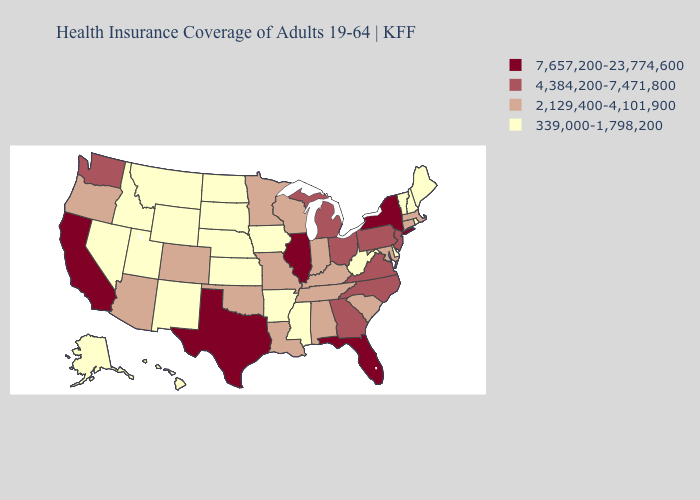Does Alabama have the same value as New Hampshire?
Write a very short answer. No. Name the states that have a value in the range 7,657,200-23,774,600?
Concise answer only. California, Florida, Illinois, New York, Texas. Name the states that have a value in the range 2,129,400-4,101,900?
Short answer required. Alabama, Arizona, Colorado, Connecticut, Indiana, Kentucky, Louisiana, Maryland, Massachusetts, Minnesota, Missouri, Oklahoma, Oregon, South Carolina, Tennessee, Wisconsin. What is the value of Illinois?
Short answer required. 7,657,200-23,774,600. Does California have the same value as Texas?
Short answer required. Yes. Which states have the highest value in the USA?
Quick response, please. California, Florida, Illinois, New York, Texas. What is the value of Virginia?
Keep it brief. 4,384,200-7,471,800. Does the first symbol in the legend represent the smallest category?
Short answer required. No. What is the value of Maryland?
Quick response, please. 2,129,400-4,101,900. Which states have the lowest value in the USA?
Short answer required. Alaska, Arkansas, Delaware, Hawaii, Idaho, Iowa, Kansas, Maine, Mississippi, Montana, Nebraska, Nevada, New Hampshire, New Mexico, North Dakota, Rhode Island, South Dakota, Utah, Vermont, West Virginia, Wyoming. Does the map have missing data?
Quick response, please. No. Name the states that have a value in the range 2,129,400-4,101,900?
Keep it brief. Alabama, Arizona, Colorado, Connecticut, Indiana, Kentucky, Louisiana, Maryland, Massachusetts, Minnesota, Missouri, Oklahoma, Oregon, South Carolina, Tennessee, Wisconsin. What is the value of New Hampshire?
Short answer required. 339,000-1,798,200. What is the value of New Jersey?
Be succinct. 4,384,200-7,471,800. Is the legend a continuous bar?
Answer briefly. No. 